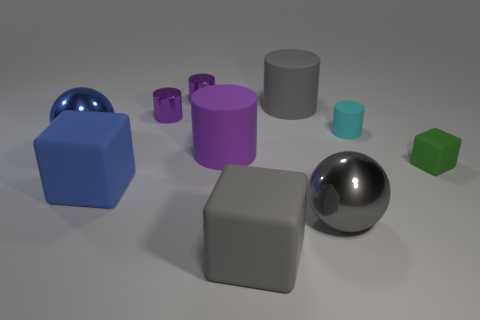Subtract all big matte cubes. How many cubes are left? 1 Subtract all cyan cylinders. How many cylinders are left? 4 Subtract 1 cylinders. How many cylinders are left? 4 Subtract all brown balls. How many green blocks are left? 1 Subtract all blocks. How many objects are left? 7 Subtract all red blocks. Subtract all yellow spheres. How many blocks are left? 3 Add 7 big purple cylinders. How many big purple cylinders are left? 8 Add 7 blue matte things. How many blue matte things exist? 8 Subtract 1 blue spheres. How many objects are left? 9 Subtract all small yellow things. Subtract all big metal things. How many objects are left? 8 